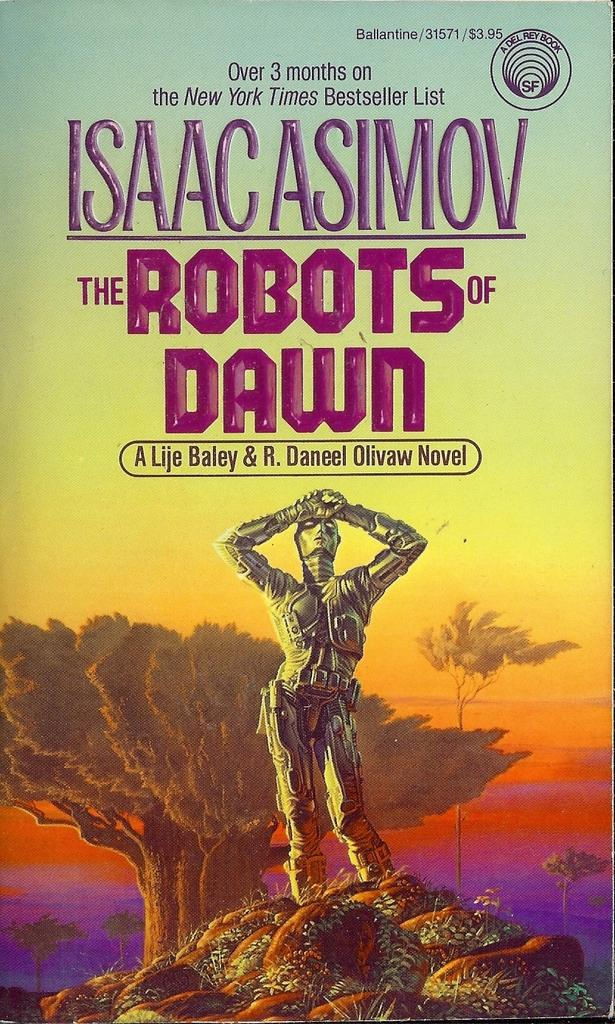<image>
Share a concise interpretation of the image provided. A book that was on the New York Times bestseller list for over 3 months. 